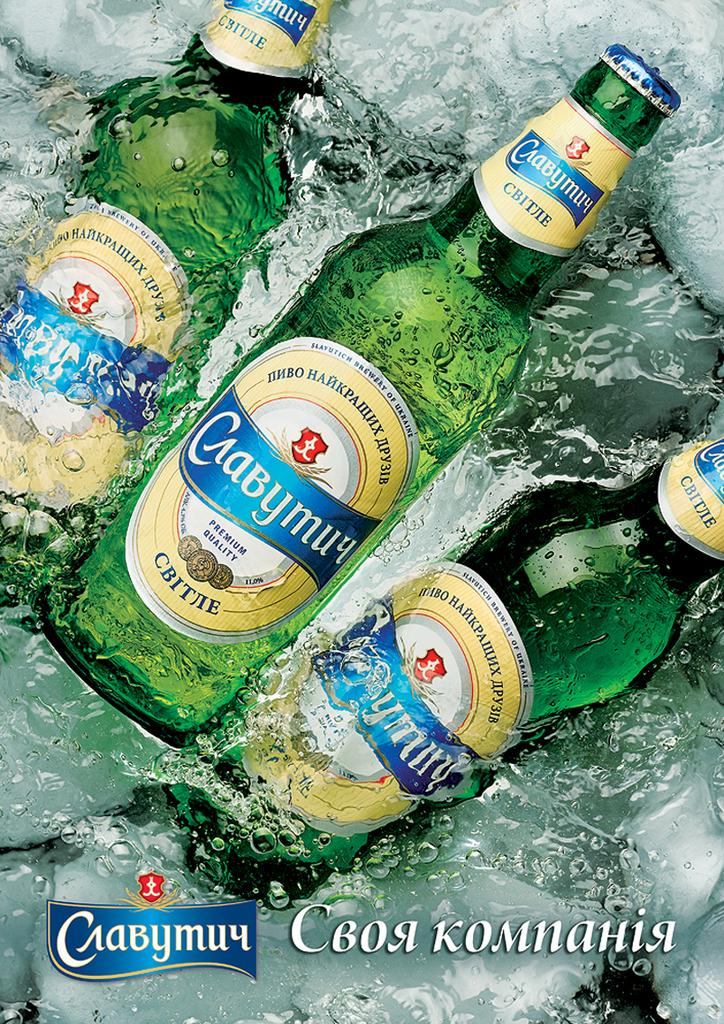<image>
Provide a brief description of the given image. Three bottles of Ukrainian beer from the Slavutich Brewery of Ukraine. 